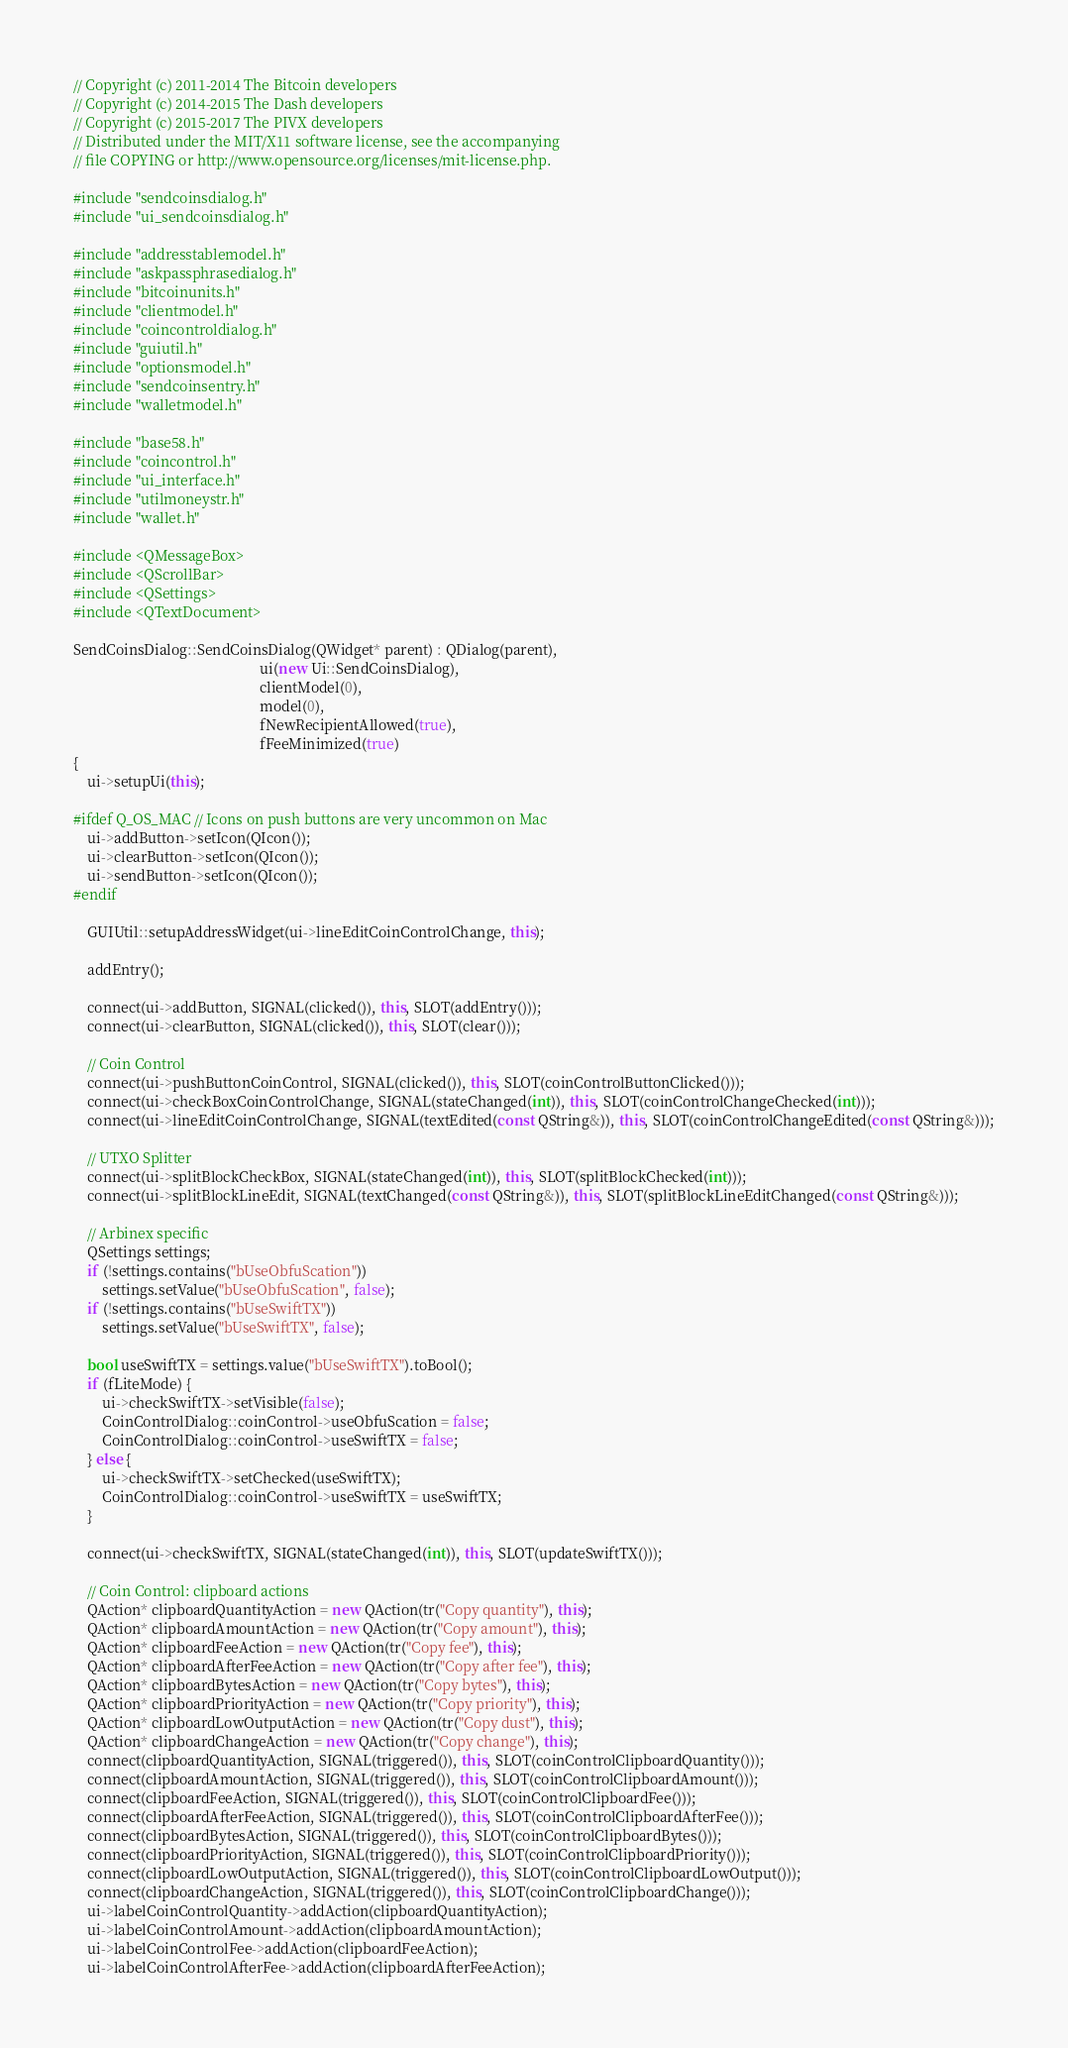Convert code to text. <code><loc_0><loc_0><loc_500><loc_500><_C++_>// Copyright (c) 2011-2014 The Bitcoin developers
// Copyright (c) 2014-2015 The Dash developers
// Copyright (c) 2015-2017 The PIVX developers
// Distributed under the MIT/X11 software license, see the accompanying
// file COPYING or http://www.opensource.org/licenses/mit-license.php.

#include "sendcoinsdialog.h"
#include "ui_sendcoinsdialog.h"

#include "addresstablemodel.h"
#include "askpassphrasedialog.h"
#include "bitcoinunits.h"
#include "clientmodel.h"
#include "coincontroldialog.h"
#include "guiutil.h"
#include "optionsmodel.h"
#include "sendcoinsentry.h"
#include "walletmodel.h"

#include "base58.h"
#include "coincontrol.h"
#include "ui_interface.h"
#include "utilmoneystr.h"
#include "wallet.h"

#include <QMessageBox>
#include <QScrollBar>
#include <QSettings>
#include <QTextDocument>

SendCoinsDialog::SendCoinsDialog(QWidget* parent) : QDialog(parent),
                                                    ui(new Ui::SendCoinsDialog),
                                                    clientModel(0),
                                                    model(0),
                                                    fNewRecipientAllowed(true),
                                                    fFeeMinimized(true)
{
    ui->setupUi(this);

#ifdef Q_OS_MAC // Icons on push buttons are very uncommon on Mac
    ui->addButton->setIcon(QIcon());
    ui->clearButton->setIcon(QIcon());
    ui->sendButton->setIcon(QIcon());
#endif

    GUIUtil::setupAddressWidget(ui->lineEditCoinControlChange, this);

    addEntry();

    connect(ui->addButton, SIGNAL(clicked()), this, SLOT(addEntry()));
    connect(ui->clearButton, SIGNAL(clicked()), this, SLOT(clear()));

    // Coin Control
    connect(ui->pushButtonCoinControl, SIGNAL(clicked()), this, SLOT(coinControlButtonClicked()));
    connect(ui->checkBoxCoinControlChange, SIGNAL(stateChanged(int)), this, SLOT(coinControlChangeChecked(int)));
    connect(ui->lineEditCoinControlChange, SIGNAL(textEdited(const QString&)), this, SLOT(coinControlChangeEdited(const QString&)));

    // UTXO Splitter
    connect(ui->splitBlockCheckBox, SIGNAL(stateChanged(int)), this, SLOT(splitBlockChecked(int)));
    connect(ui->splitBlockLineEdit, SIGNAL(textChanged(const QString&)), this, SLOT(splitBlockLineEditChanged(const QString&)));

    // Arbinex specific
    QSettings settings;
    if (!settings.contains("bUseObfuScation"))
        settings.setValue("bUseObfuScation", false);
    if (!settings.contains("bUseSwiftTX"))
        settings.setValue("bUseSwiftTX", false);

    bool useSwiftTX = settings.value("bUseSwiftTX").toBool();
    if (fLiteMode) {
        ui->checkSwiftTX->setVisible(false);
        CoinControlDialog::coinControl->useObfuScation = false;
        CoinControlDialog::coinControl->useSwiftTX = false;
    } else {
        ui->checkSwiftTX->setChecked(useSwiftTX);
        CoinControlDialog::coinControl->useSwiftTX = useSwiftTX;
    }

    connect(ui->checkSwiftTX, SIGNAL(stateChanged(int)), this, SLOT(updateSwiftTX()));

    // Coin Control: clipboard actions
    QAction* clipboardQuantityAction = new QAction(tr("Copy quantity"), this);
    QAction* clipboardAmountAction = new QAction(tr("Copy amount"), this);
    QAction* clipboardFeeAction = new QAction(tr("Copy fee"), this);
    QAction* clipboardAfterFeeAction = new QAction(tr("Copy after fee"), this);
    QAction* clipboardBytesAction = new QAction(tr("Copy bytes"), this);
    QAction* clipboardPriorityAction = new QAction(tr("Copy priority"), this);
    QAction* clipboardLowOutputAction = new QAction(tr("Copy dust"), this);
    QAction* clipboardChangeAction = new QAction(tr("Copy change"), this);
    connect(clipboardQuantityAction, SIGNAL(triggered()), this, SLOT(coinControlClipboardQuantity()));
    connect(clipboardAmountAction, SIGNAL(triggered()), this, SLOT(coinControlClipboardAmount()));
    connect(clipboardFeeAction, SIGNAL(triggered()), this, SLOT(coinControlClipboardFee()));
    connect(clipboardAfterFeeAction, SIGNAL(triggered()), this, SLOT(coinControlClipboardAfterFee()));
    connect(clipboardBytesAction, SIGNAL(triggered()), this, SLOT(coinControlClipboardBytes()));
    connect(clipboardPriorityAction, SIGNAL(triggered()), this, SLOT(coinControlClipboardPriority()));
    connect(clipboardLowOutputAction, SIGNAL(triggered()), this, SLOT(coinControlClipboardLowOutput()));
    connect(clipboardChangeAction, SIGNAL(triggered()), this, SLOT(coinControlClipboardChange()));
    ui->labelCoinControlQuantity->addAction(clipboardQuantityAction);
    ui->labelCoinControlAmount->addAction(clipboardAmountAction);
    ui->labelCoinControlFee->addAction(clipboardFeeAction);
    ui->labelCoinControlAfterFee->addAction(clipboardAfterFeeAction);</code> 